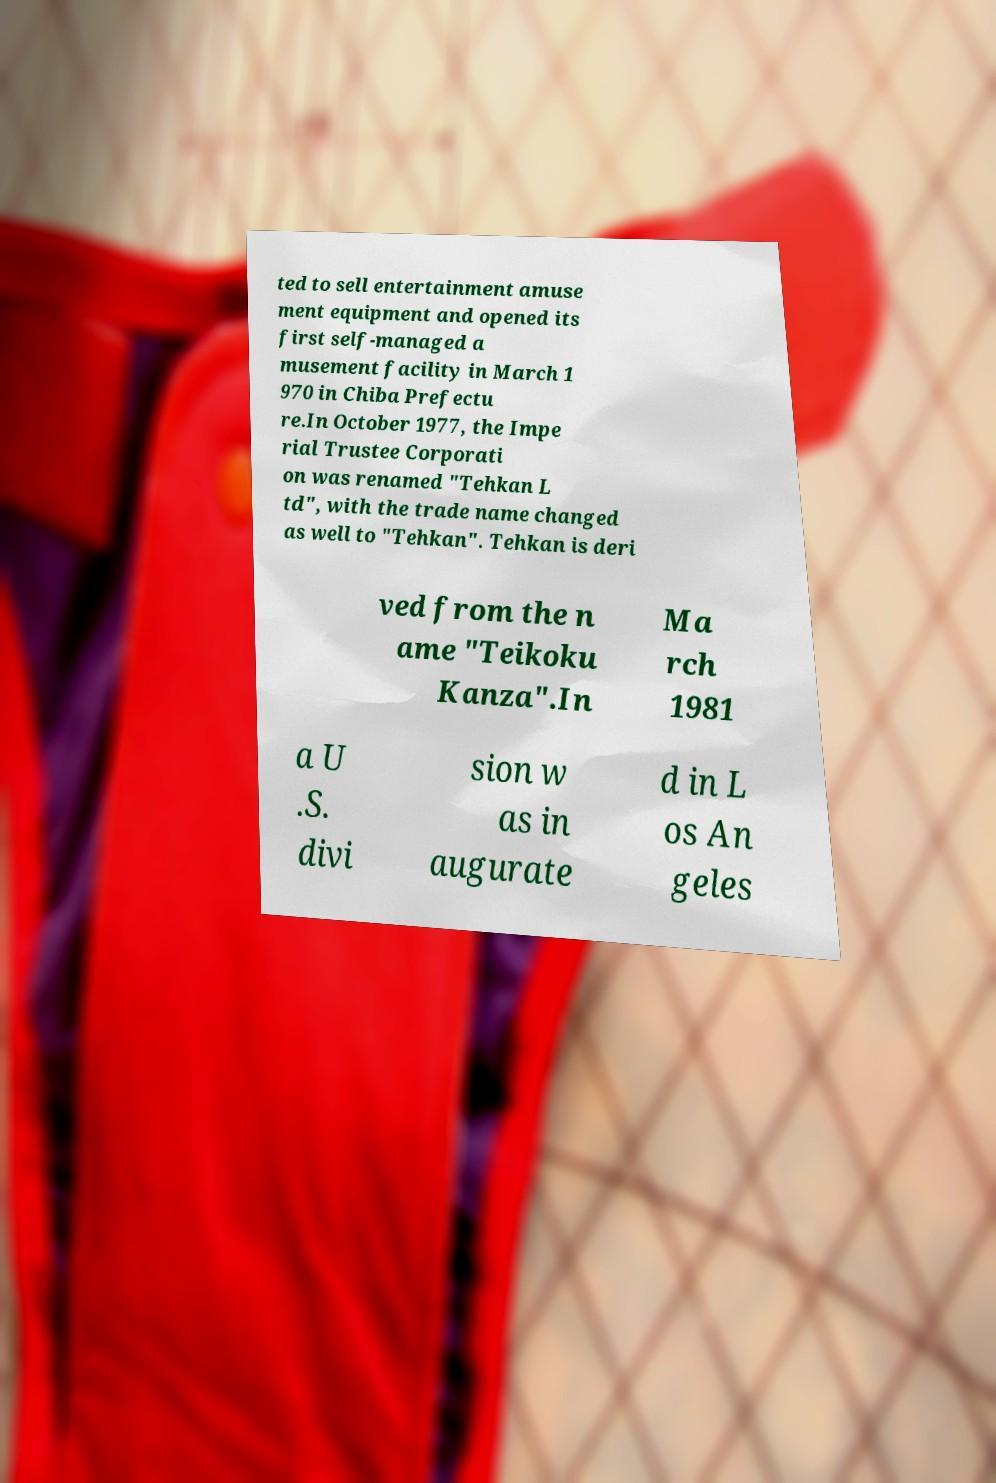There's text embedded in this image that I need extracted. Can you transcribe it verbatim? ted to sell entertainment amuse ment equipment and opened its first self-managed a musement facility in March 1 970 in Chiba Prefectu re.In October 1977, the Impe rial Trustee Corporati on was renamed "Tehkan L td", with the trade name changed as well to "Tehkan". Tehkan is deri ved from the n ame "Teikoku Kanza".In Ma rch 1981 a U .S. divi sion w as in augurate d in L os An geles 